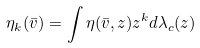Convert formula to latex. <formula><loc_0><loc_0><loc_500><loc_500>\eta _ { k } ( \bar { v } ) = \int \eta ( \bar { v } , z ) z ^ { k } d \lambda _ { c } ( z )</formula> 